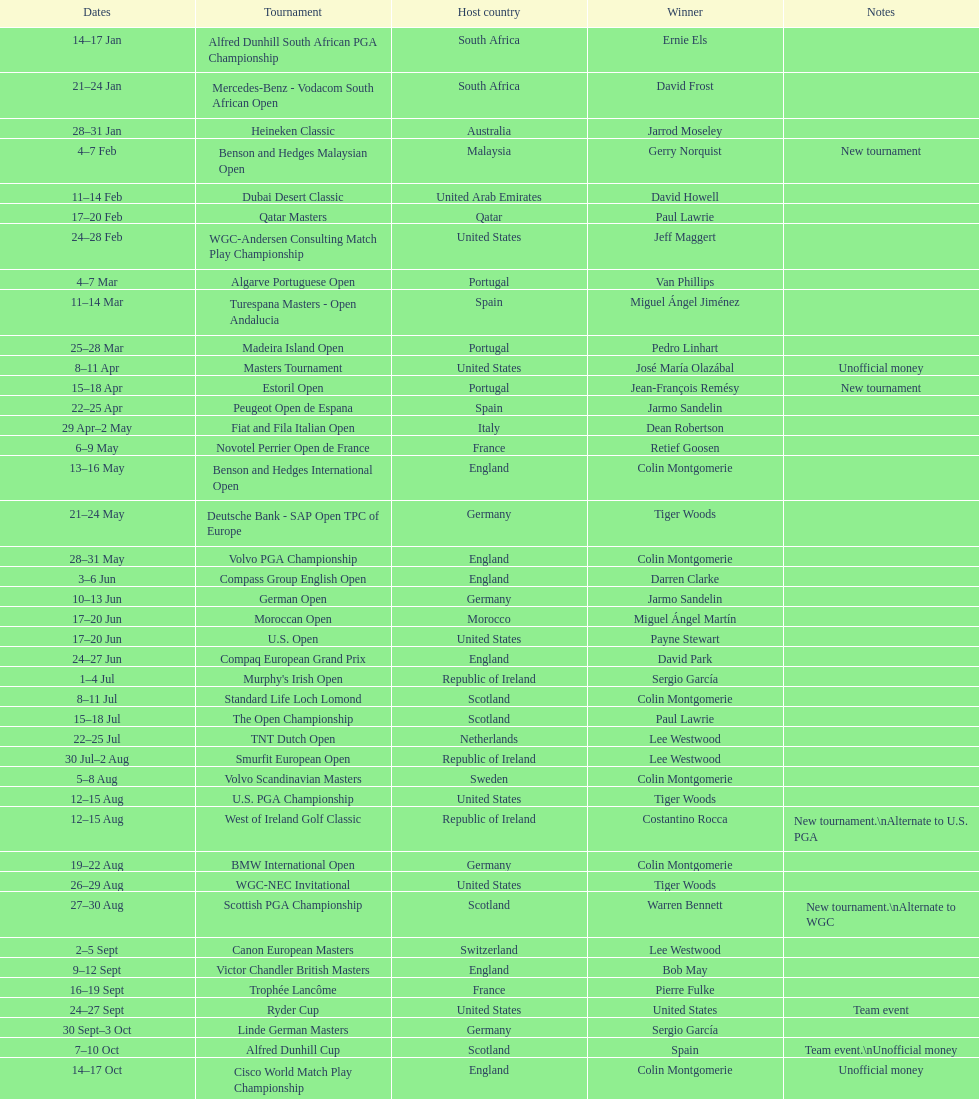Which competition took place more recently, the volvo pga or the algarve portuguese open? Volvo PGA. Parse the full table. {'header': ['Dates', 'Tournament', 'Host country', 'Winner', 'Notes'], 'rows': [['14–17\xa0Jan', 'Alfred Dunhill South African PGA Championship', 'South Africa', 'Ernie Els', ''], ['21–24\xa0Jan', 'Mercedes-Benz - Vodacom South African Open', 'South Africa', 'David Frost', ''], ['28–31\xa0Jan', 'Heineken Classic', 'Australia', 'Jarrod Moseley', ''], ['4–7\xa0Feb', 'Benson and Hedges Malaysian Open', 'Malaysia', 'Gerry Norquist', 'New tournament'], ['11–14\xa0Feb', 'Dubai Desert Classic', 'United Arab Emirates', 'David Howell', ''], ['17–20\xa0Feb', 'Qatar Masters', 'Qatar', 'Paul Lawrie', ''], ['24–28\xa0Feb', 'WGC-Andersen Consulting Match Play Championship', 'United States', 'Jeff Maggert', ''], ['4–7\xa0Mar', 'Algarve Portuguese Open', 'Portugal', 'Van Phillips', ''], ['11–14\xa0Mar', 'Turespana Masters - Open Andalucia', 'Spain', 'Miguel Ángel Jiménez', ''], ['25–28\xa0Mar', 'Madeira Island Open', 'Portugal', 'Pedro Linhart', ''], ['8–11\xa0Apr', 'Masters Tournament', 'United States', 'José María Olazábal', 'Unofficial money'], ['15–18\xa0Apr', 'Estoril Open', 'Portugal', 'Jean-François Remésy', 'New tournament'], ['22–25\xa0Apr', 'Peugeot Open de Espana', 'Spain', 'Jarmo Sandelin', ''], ['29\xa0Apr–2\xa0May', 'Fiat and Fila Italian Open', 'Italy', 'Dean Robertson', ''], ['6–9\xa0May', 'Novotel Perrier Open de France', 'France', 'Retief Goosen', ''], ['13–16\xa0May', 'Benson and Hedges International Open', 'England', 'Colin Montgomerie', ''], ['21–24\xa0May', 'Deutsche Bank - SAP Open TPC of Europe', 'Germany', 'Tiger Woods', ''], ['28–31\xa0May', 'Volvo PGA Championship', 'England', 'Colin Montgomerie', ''], ['3–6\xa0Jun', 'Compass Group English Open', 'England', 'Darren Clarke', ''], ['10–13\xa0Jun', 'German Open', 'Germany', 'Jarmo Sandelin', ''], ['17–20\xa0Jun', 'Moroccan Open', 'Morocco', 'Miguel Ángel Martín', ''], ['17–20\xa0Jun', 'U.S. Open', 'United States', 'Payne Stewart', ''], ['24–27\xa0Jun', 'Compaq European Grand Prix', 'England', 'David Park', ''], ['1–4\xa0Jul', "Murphy's Irish Open", 'Republic of Ireland', 'Sergio García', ''], ['8–11\xa0Jul', 'Standard Life Loch Lomond', 'Scotland', 'Colin Montgomerie', ''], ['15–18\xa0Jul', 'The Open Championship', 'Scotland', 'Paul Lawrie', ''], ['22–25\xa0Jul', 'TNT Dutch Open', 'Netherlands', 'Lee Westwood', ''], ['30\xa0Jul–2\xa0Aug', 'Smurfit European Open', 'Republic of Ireland', 'Lee Westwood', ''], ['5–8\xa0Aug', 'Volvo Scandinavian Masters', 'Sweden', 'Colin Montgomerie', ''], ['12–15\xa0Aug', 'U.S. PGA Championship', 'United States', 'Tiger Woods', ''], ['12–15\xa0Aug', 'West of Ireland Golf Classic', 'Republic of Ireland', 'Costantino Rocca', 'New tournament.\\nAlternate to U.S. PGA'], ['19–22\xa0Aug', 'BMW International Open', 'Germany', 'Colin Montgomerie', ''], ['26–29\xa0Aug', 'WGC-NEC Invitational', 'United States', 'Tiger Woods', ''], ['27–30\xa0Aug', 'Scottish PGA Championship', 'Scotland', 'Warren Bennett', 'New tournament.\\nAlternate to WGC'], ['2–5\xa0Sept', 'Canon European Masters', 'Switzerland', 'Lee Westwood', ''], ['9–12\xa0Sept', 'Victor Chandler British Masters', 'England', 'Bob May', ''], ['16–19\xa0Sept', 'Trophée Lancôme', 'France', 'Pierre Fulke', ''], ['24–27\xa0Sept', 'Ryder Cup', 'United States', 'United States', 'Team event'], ['30\xa0Sept–3\xa0Oct', 'Linde German Masters', 'Germany', 'Sergio García', ''], ['7–10\xa0Oct', 'Alfred Dunhill Cup', 'Scotland', 'Spain', 'Team event.\\nUnofficial money'], ['14–17\xa0Oct', 'Cisco World Match Play Championship', 'England', 'Colin Montgomerie', 'Unofficial money'], ['14–17\xa0Oct', 'Sarazen World Open', 'Spain', 'Thomas Bjørn', 'New tournament'], ['21–24\xa0Oct', 'Belgacom Open', 'Belgium', 'Robert Karlsson', ''], ['28–31\xa0Oct', 'Volvo Masters', 'Spain', 'Miguel Ángel Jiménez', ''], ['4–7\xa0Nov', 'WGC-American Express Championship', 'Spain', 'Tiger Woods', ''], ['18–21\xa0Nov', 'World Cup of Golf', 'Malaysia', 'United States', 'Team event.\\nUnofficial money']]} 